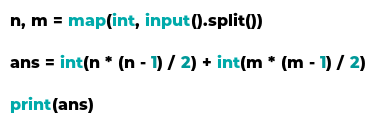Convert code to text. <code><loc_0><loc_0><loc_500><loc_500><_Python_>n, m = map(int, input().split())

ans = int(n * (n - 1) / 2) + int(m * (m - 1) / 2)

print(ans)</code> 